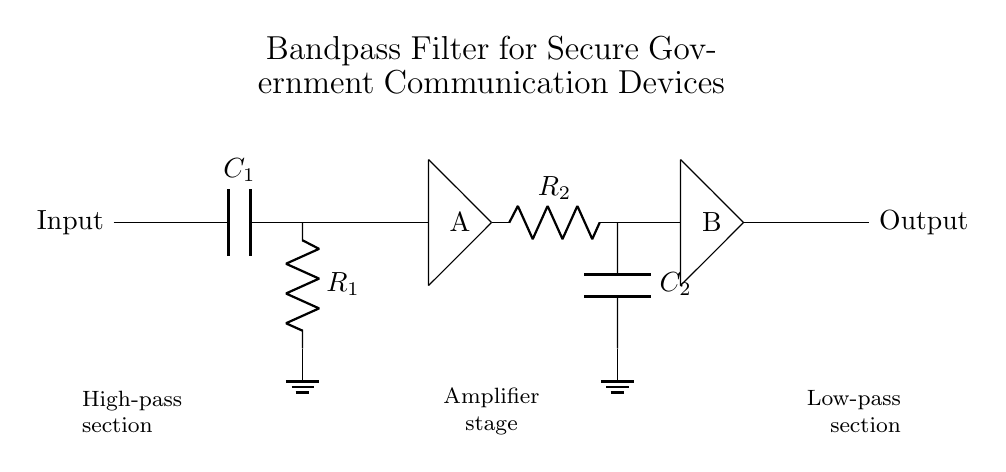What are the components used in the high-pass section? The high-pass section consists of a capacitor labeled C1 and a resistor labeled R1, connected in series, with R1 leading to ground.
Answer: C1, R1 What is the function of the amplifier stage? The amplifier stage serves to boost the signal between the high-pass section and the low-pass section, ensuring that the desired frequencies are adequately emphasized.
Answer: Boost signal What is the role of the low-pass section? The low-pass section contains a resistor labeled R2 and a capacitor labeled C2, designed to filter out frequencies above a certain cutoff frequency, allowing only lower frequencies to pass through.
Answer: Filter higher frequencies How many distinct stages are present in the filter circuit? The circuit has three distinct sections: a high-pass section, an amplifier stage, and a low-pass section, each performing specific roles in frequency selection.
Answer: Three Which two components define the cutoff frequencies of this circuit? The cutoff frequencies are determined by the capacitor C1 and the resistor R1 in the high-pass section, along with capacitor C2 and resistor R2 in the low-pass section.
Answer: C1, R1, C2, R2 What is the input to output relationship in terms of signal? The input signal enters the circuit, passes through the high-pass filter to remove low frequencies, is amplified, and then passes through the low-pass filter to remove high frequencies before appearing at the output.
Answer: Frequency selective filtering 